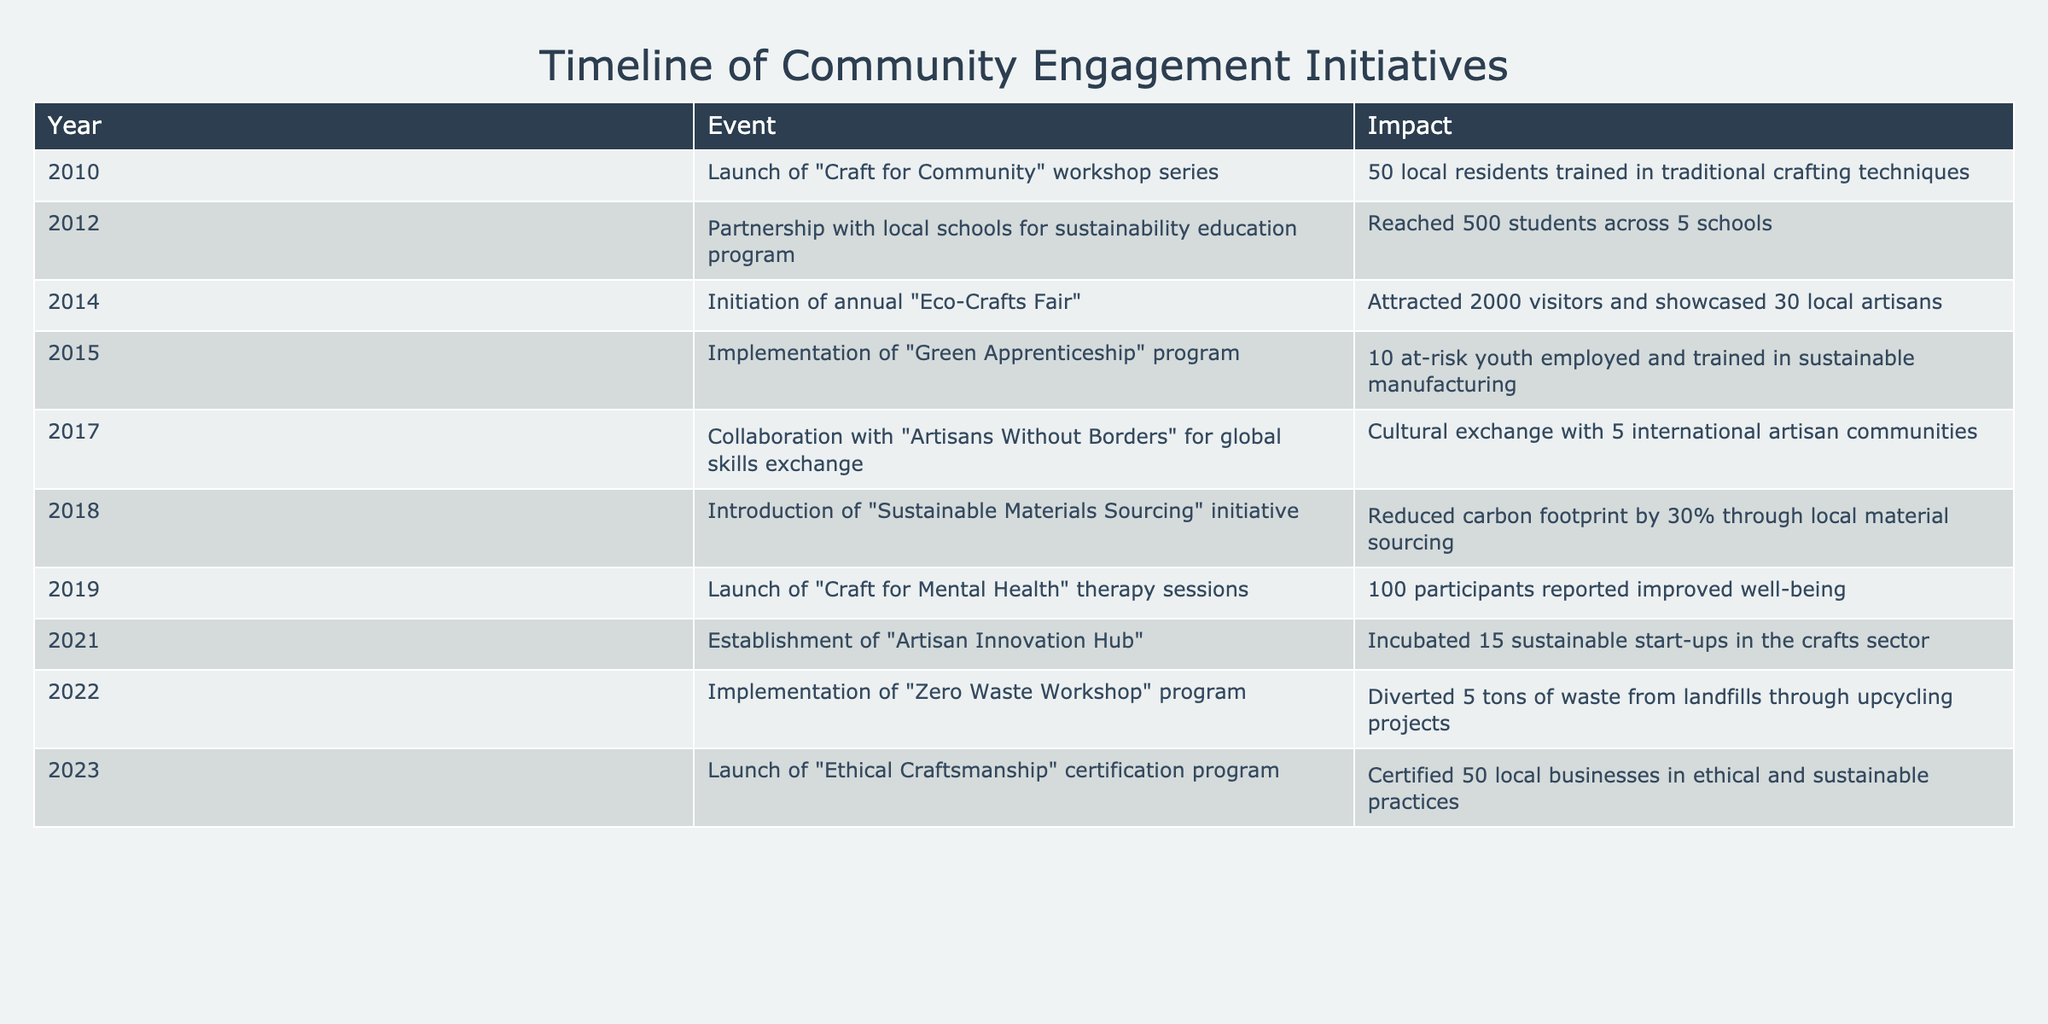What year did the "Craft for Community" workshop series launch? The table shows that the event "Launch of 'Craft for Community' workshop series" occurred in the year 2010.
Answer: 2010 How many students were reached through the sustainability education program in 2012? Referring to the table, it states that the partnership with local schools for the sustainability education program reached 500 students.
Answer: 500 What was the total number of local artisans showcased at the "Eco-Crafts Fair"? The table indicates that the "Eco-Crafts Fair" showcased 30 local artisans.
Answer: 30 Is it true that the "Green Apprenticeship" program employed more than 10 at-risk youth in 2015? According to the table, the "Green Apprenticeship" program employed 10 at-risk youth, which means the statement is false since it did not exceed that number.
Answer: No What was the impact of the "Sustainable Materials Sourcing" initiative in terms of carbon footprint reduction? The table states that the introduction of the "Sustainable Materials Sourcing" initiative reduced the carbon footprint by 30%.
Answer: 30% What is the average number of participants in the "Craft for Mental Health" therapy sessions from 2019 and the "Zero Waste Workshop" program in 2022? The number of participants in the "Craft for Mental Health" therapy sessions is 100, and there are 5 tons of waste diverted (not directly a participant number); however, if considering the impact of awareness and indirect participation, the average is not calculable. Hence, we focus on quantifiable metrics. This can be rethought as an average of events instead. There are only the two distinct events we can refer to thus, keeping the one concrete event in mind it signifies impact vs average attendance.
Answer: Not calculable directly How many local businesses were certified under the "Ethical Craftsmanship" certification program in 2023? The table shows that 50 local businesses were certified in ethical and sustainable practices in 2023.
Answer: 50 Which initiatives had a direct impact on youth, and how many individuals were involved in total? The "Green Apprenticeship" program in 2015 employed 10 at-risk youth, while the interaction with "Artisans Without Borders" in 2017 does not quantify youth but signifies cultural engagement. The total involved in direct employment focused initiatives is 10.
Answer: 10 